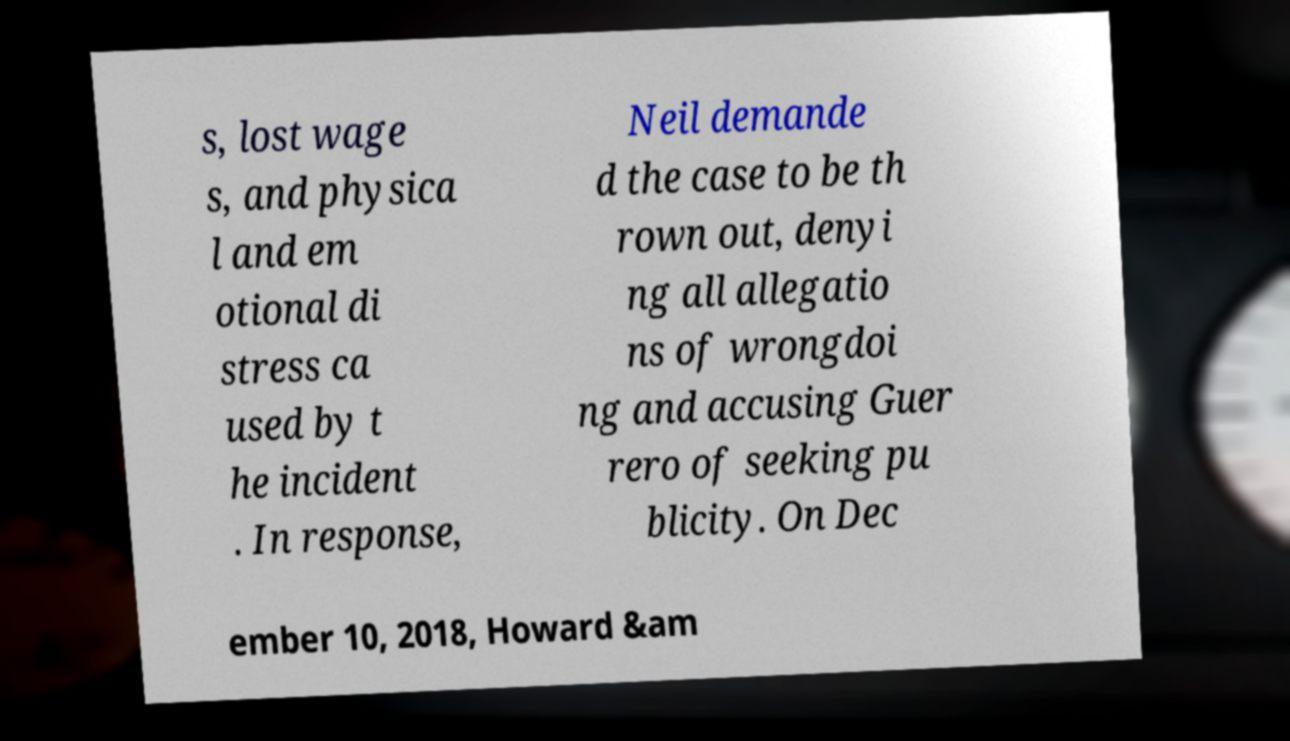There's text embedded in this image that I need extracted. Can you transcribe it verbatim? s, lost wage s, and physica l and em otional di stress ca used by t he incident . In response, Neil demande d the case to be th rown out, denyi ng all allegatio ns of wrongdoi ng and accusing Guer rero of seeking pu blicity. On Dec ember 10, 2018, Howard &am 